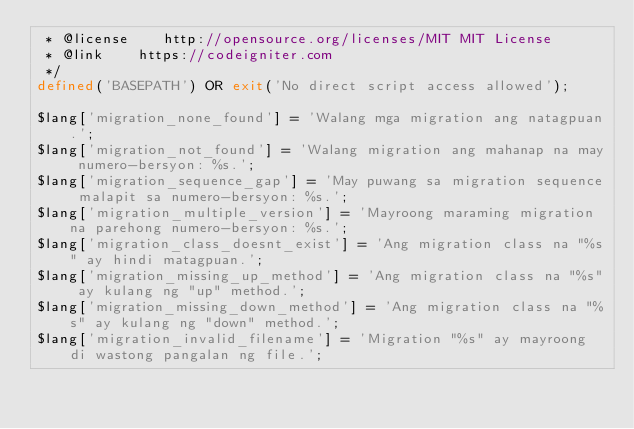<code> <loc_0><loc_0><loc_500><loc_500><_PHP_> * @license    http://opensource.org/licenses/MIT MIT License
 * @link    https://codeigniter.com
 */
defined('BASEPATH') OR exit('No direct script access allowed');

$lang['migration_none_found'] = 'Walang mga migration ang natagpuan.';
$lang['migration_not_found'] = 'Walang migration ang mahanap na may numero-bersyon: %s.';
$lang['migration_sequence_gap'] = 'May puwang sa migration sequence malapit sa numero-bersyon: %s.';
$lang['migration_multiple_version'] = 'Mayroong maraming migration na parehong numero-bersyon: %s.';
$lang['migration_class_doesnt_exist'] = 'Ang migration class na "%s" ay hindi matagpuan.';
$lang['migration_missing_up_method'] = 'Ang migration class na "%s" ay kulang ng "up" method.';
$lang['migration_missing_down_method'] = 'Ang migration class na "%s" ay kulang ng "down" method.';
$lang['migration_invalid_filename'] = 'Migration "%s" ay mayroong di wastong pangalan ng file.';
</code> 